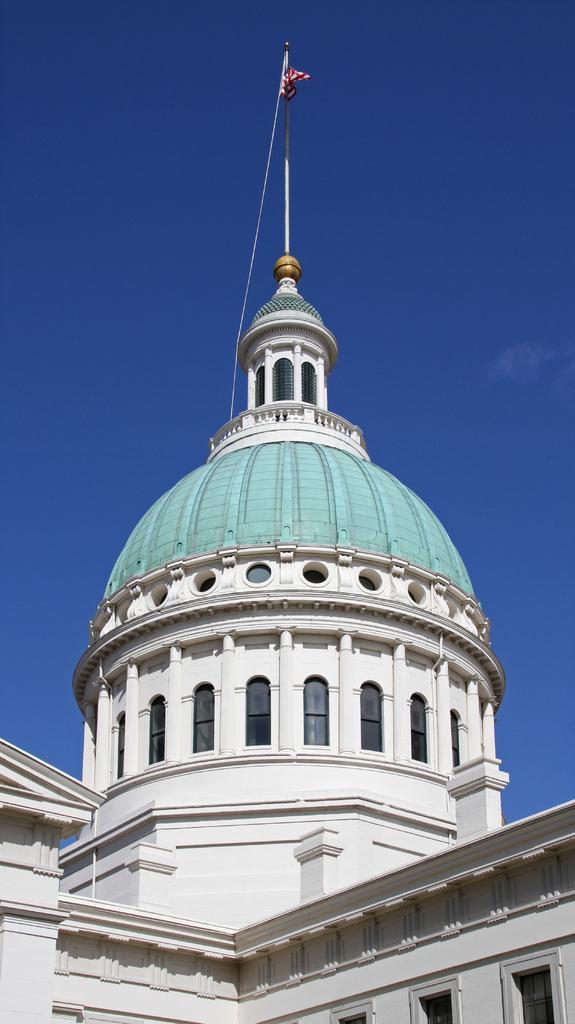What is the main structure visible in the image? There is a white color monument in the image. What is attached to the monument in the image? There is a flag in the image. What color is the sky in the background of the image? The sky is blue in the background of the image. What type of bone can be seen in the image? There is no bone present in the image; it features a white color monument and a flag. 